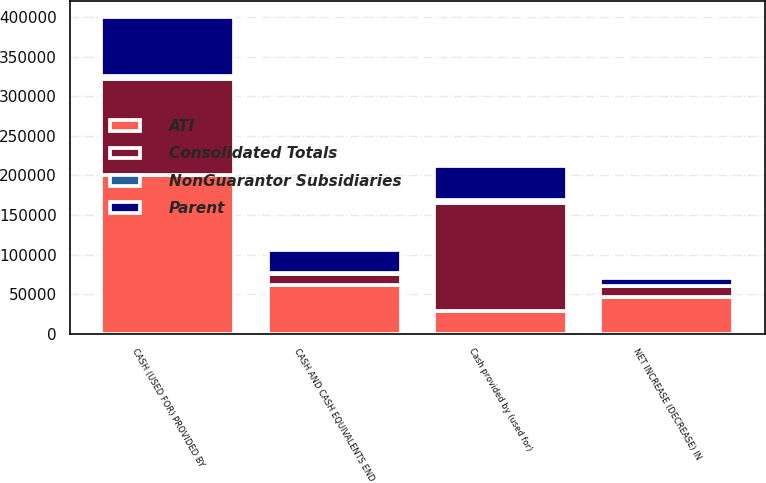Convert chart to OTSL. <chart><loc_0><loc_0><loc_500><loc_500><stacked_bar_chart><ecel><fcel>CASH (USED FOR) PROVIDED BY<fcel>Cash provided by (used for)<fcel>NET INCREASE (DECREASE) IN<fcel>CASH AND CASH EQUIVALENTS END<nl><fcel>Consolidated Totals<fcel>121884<fcel>135801<fcel>13917<fcel>13917<nl><fcel>ATI<fcel>200737<fcel>28903<fcel>45791<fcel>61809<nl><fcel>NonGuarantor Subsidiaries<fcel>3731<fcel>4762<fcel>80<fcel>836<nl><fcel>Parent<fcel>73802<fcel>42358<fcel>9967<fcel>28903<nl></chart> 